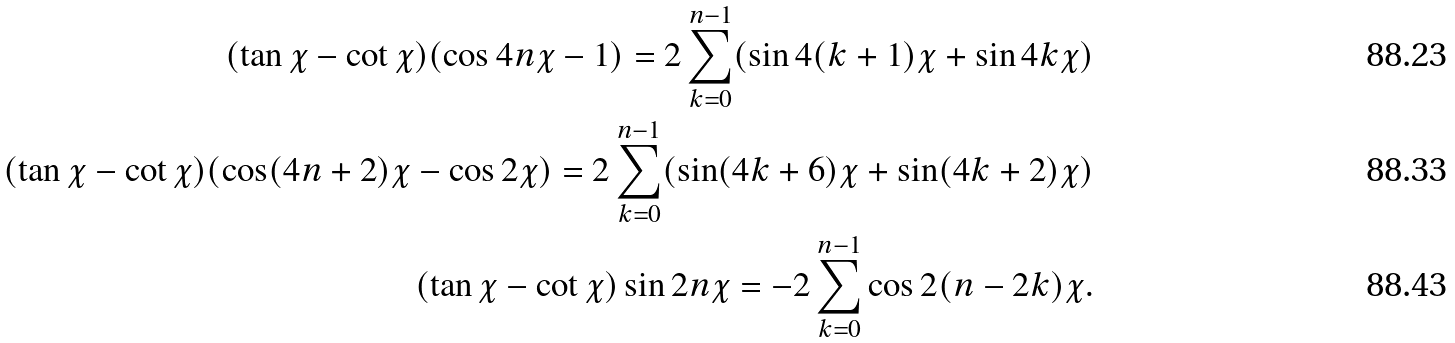Convert formula to latex. <formula><loc_0><loc_0><loc_500><loc_500>( \tan \chi - \cot \chi ) ( \cos 4 n \chi - 1 ) = 2 \sum _ { k = 0 } ^ { n - 1 } ( \sin 4 ( k + 1 ) \chi + \sin 4 k \chi ) \\ ( \tan \chi - \cot \chi ) ( \cos ( 4 n + 2 ) \chi - \cos 2 \chi ) = 2 \sum _ { k = 0 } ^ { n - 1 } ( \sin ( 4 k + 6 ) \chi + \sin ( 4 k + 2 ) \chi ) \\ ( \tan \chi - \cot \chi ) \sin 2 n \chi = - 2 \sum _ { k = 0 } ^ { n - 1 } \cos 2 ( n - 2 k ) \chi .</formula> 